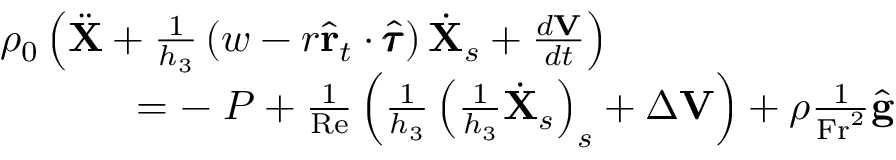<formula> <loc_0><loc_0><loc_500><loc_500>\begin{array} { r } { \rho _ { 0 } \left ( \ddot { X } + \frac { 1 } { h _ { 3 } } \left ( w - r \hat { r } _ { t } \cdot \hat { \pm b { \tau } } \right ) \dot { X } _ { s } + \frac { d V } { d t } \right ) \quad } \\ { = - \nabla P + \frac { 1 } { R e } \left ( \frac { 1 } { h _ { 3 } } \left ( \frac { 1 } { h _ { 3 } } \dot { X } _ { s } \right ) _ { s } + \Delta V \right ) + \rho \frac { 1 } { F r ^ { 2 } } \hat { g } } \end{array}</formula> 